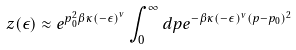Convert formula to latex. <formula><loc_0><loc_0><loc_500><loc_500>z ( \epsilon ) \approx e ^ { p _ { 0 } ^ { 2 } \beta \kappa \left ( - \epsilon \right ) ^ { \nu } } \int _ { 0 } ^ { \infty } d p e ^ { - \beta \kappa ( - \epsilon ) ^ { \nu } ( p - p _ { 0 } ) ^ { 2 } }</formula> 